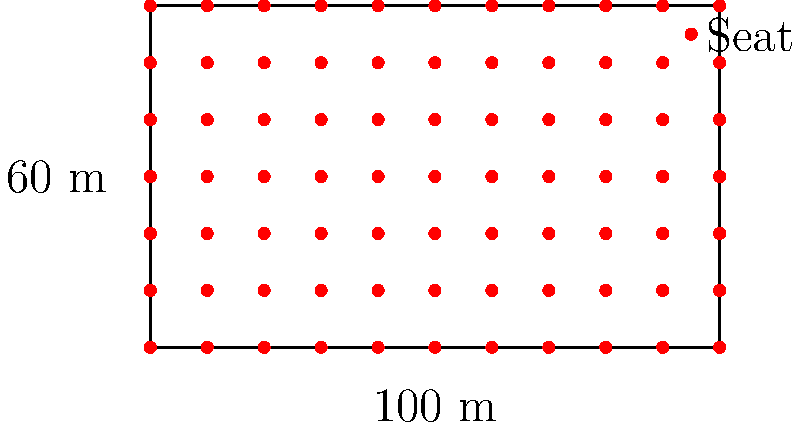As the champion athlete planning your celebration, you need to determine the maximum occupancy for a section of the stadium. The section measures 100 m wide and 60 m deep, with seats arranged in a grid pattern. Each seat occupies a 1 m x 1 m space, and there must be a 1 m wide aisle between every 10 seats in both directions for safety. Calculate the maximum number of seats that can be placed in this section. To solve this problem, we'll follow these steps:

1. Calculate the number of seats in a row:
   - Total width = 100 m
   - Space for seats in a row = 90 m (9 groups of 10 seats)
   - Number of seats in a row = 90

2. Calculate the number of rows:
   - Total depth = 60 m
   - Space for seats in depth = 54 m (9 groups of 6 seats)
   - Number of rows = 54

3. Calculate the total number of seats:
   $$\text{Total seats} = \text{Seats per row} \times \text{Number of rows}$$
   $$\text{Total seats} = 90 \times 54 = 4,860$$

Therefore, the maximum number of seats that can be placed in this section, accounting for the required aisles, is 4,860.
Answer: 4,860 seats 